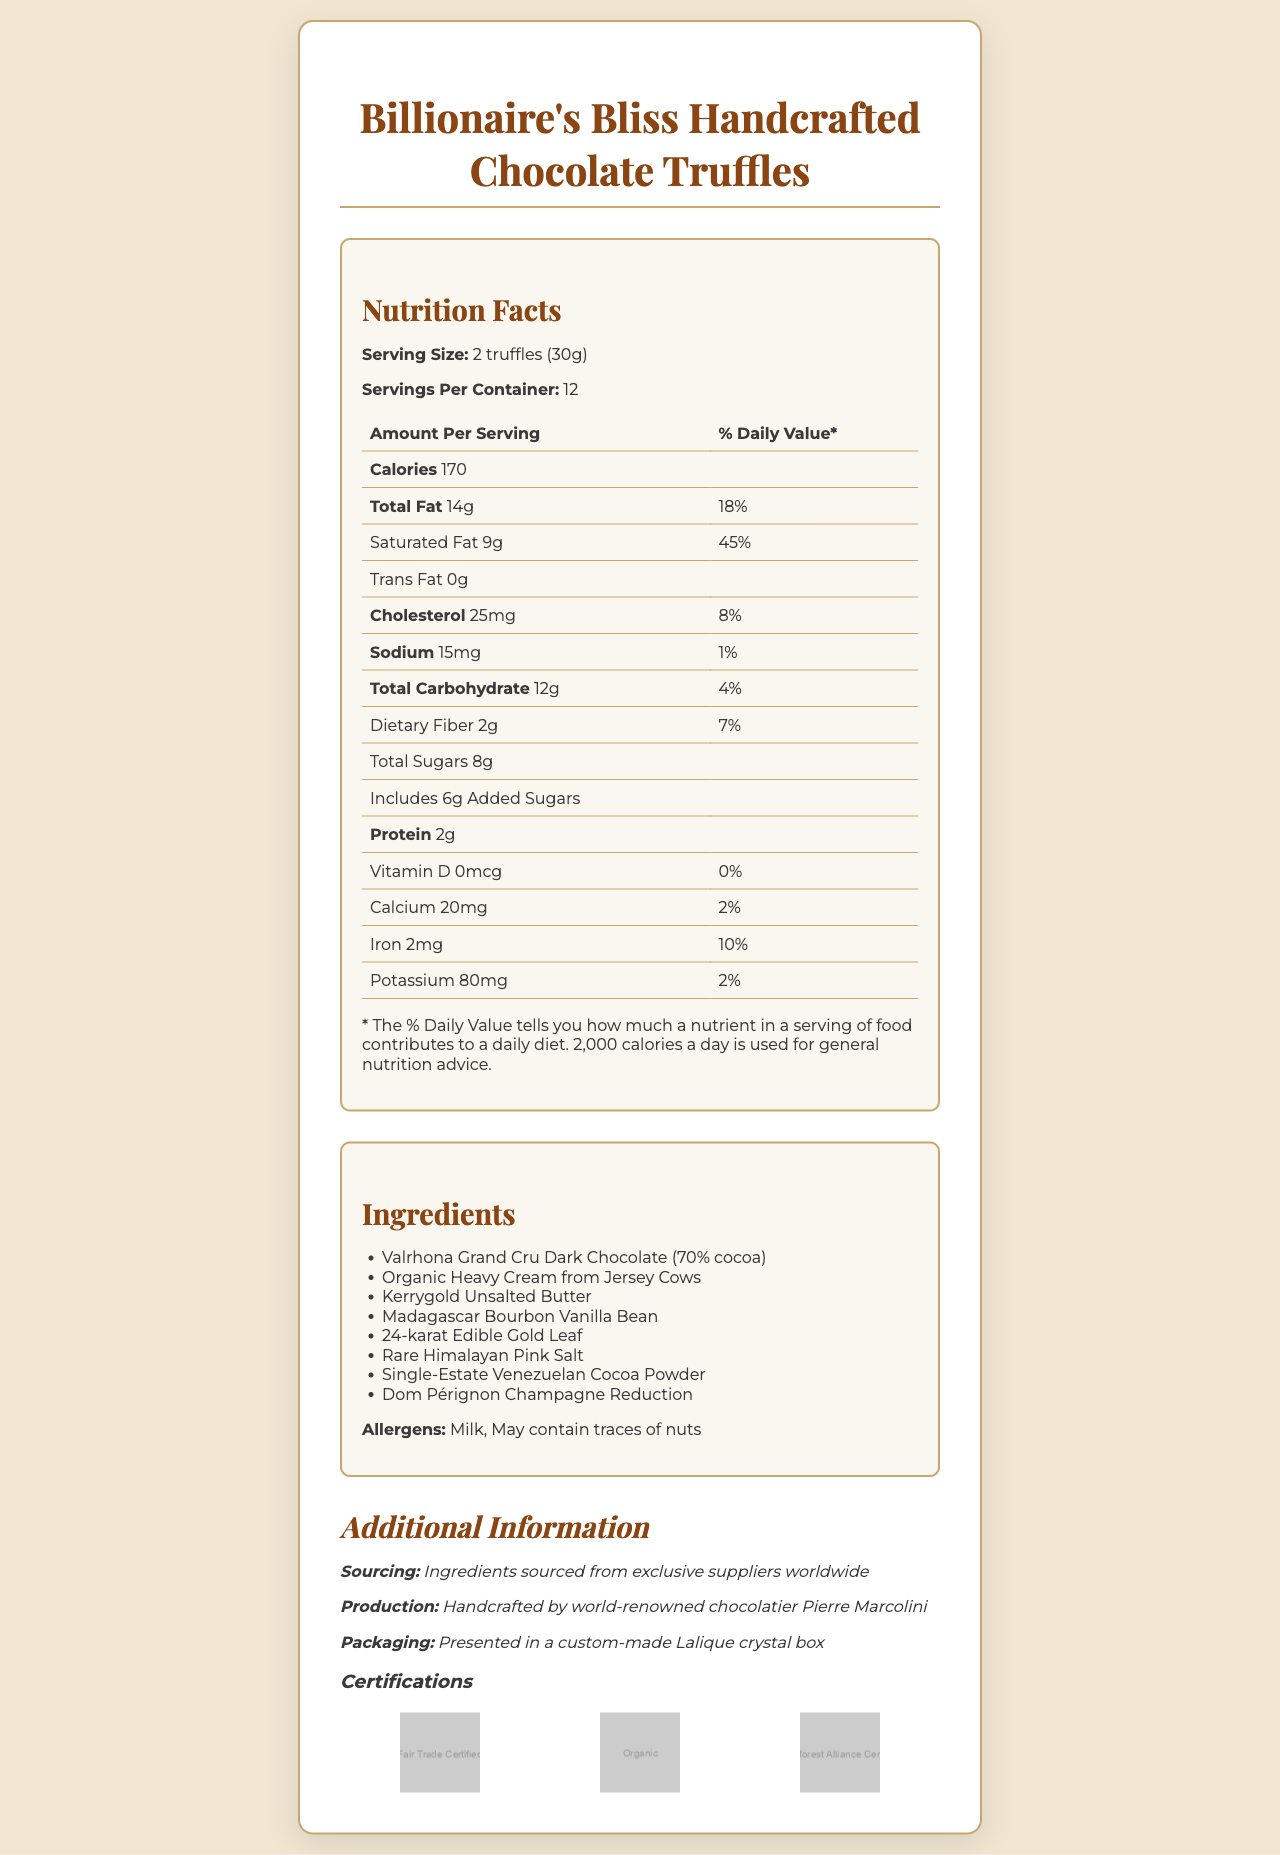what is the serving size? The serving size is explicitly stated as "2 truffles (30g)".
Answer: 2 truffles (30g) how many calories are in one serving? The document states the number of calories per serving under the nutrition facts section, which is 170 calories.
Answer: 170 which ingredient is used to add a touch of luxury to the truffles? The ingredient list includes "24-karat Edible Gold Leaf," indicating the luxurious touch.
Answer: 24-karat Edible Gold Leaf how many servings are there per container? The number of servings per container is 12, as mentioned clearly in the document.
Answer: 12 list all the allergens mentioned in the document The allergens section lists "Milk" and "May contain traces of nuts."
Answer: Milk, May contain traces of nuts which of the following is not an ingredient in these truffles? A. Valrhona Grand Cru Dark Chocolate B. Organic Heavy Cream C. Almond pieces D. Madagascar Bourbon Vanilla Bean Almond pieces are not listed as an ingredient, while the other options are.
Answer: C what is the percentage daily value of saturated fat? A. 25% B. 30% C. 45% D. 50% The % Daily Value for saturated fat is listed as 45%.
Answer: C are these truffles Fair Trade Certified? The additional information section lists "Fair Trade Certified" as one of the certifications.
Answer: Yes describe the entire document and its purpose The document outlines details about the product, such as its nutritional content, ingredients, serving size, allergens, and additional informational aspects like sourcing, production, and certifications.
Answer: The document provides comprehensive nutritional information, ingredients, allergens, additional details, and certifications for Billionaire's Bliss Handcrafted Chocolate Truffles. It highlights the luxurious nature of the product through its premium ingredients and elegant packaging procedure. who is the chocolatier that handcrafts the truffles? Under the additional information section, it states that the truffles are handcrafted by world-renowned chocolatier Pierre Marcolini.
Answer: Pierre Marcolini what mineral content is highest in these truffles besides iron? The vitamins and minerals section lists potassium as having 80mg, which is higher than calcium's 20mg and vitamin D's 0mcg, besides iron's 2mg.
Answer: Potassium can nutrition facts determine if these truffles are gluten-free? The document does not provide sufficient information to determine whether the truffles are gluten-free. There is no mention of gluten or gluten-containing ingredients.
Answer: Not enough information 